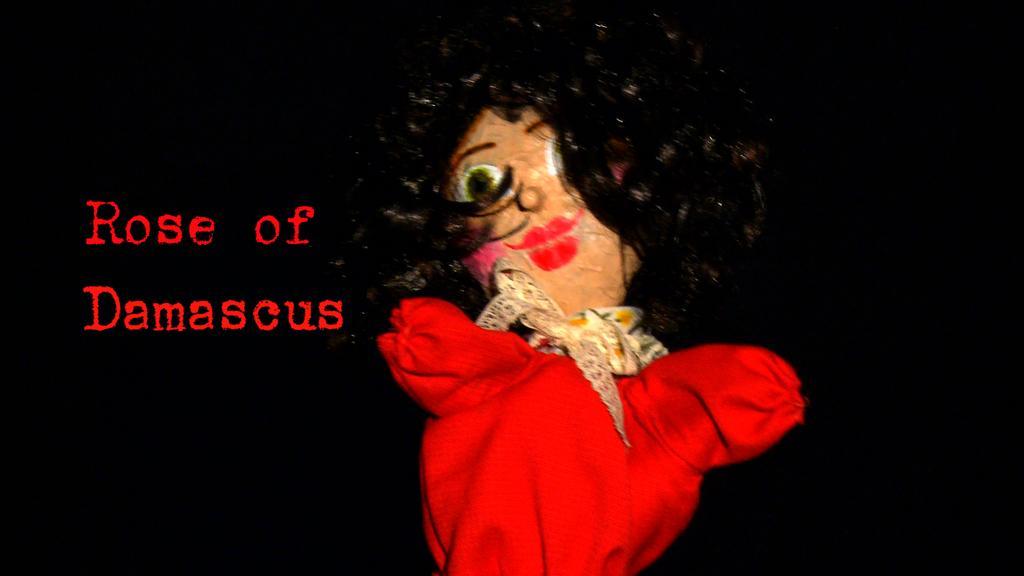How would you summarize this image in a sentence or two? In the center of the image there is a doll. On the right there is a text. 